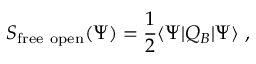<formula> <loc_0><loc_0><loc_500><loc_500>S _ { f r e e o p e n } ( \Psi ) = { \frac { 1 } { 2 } } \langle \Psi | Q _ { B } | \Psi \rangle \ ,</formula> 